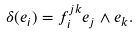<formula> <loc_0><loc_0><loc_500><loc_500>\delta ( e _ { i } ) = f _ { i } ^ { j k } e _ { j } \wedge e _ { k } .</formula> 